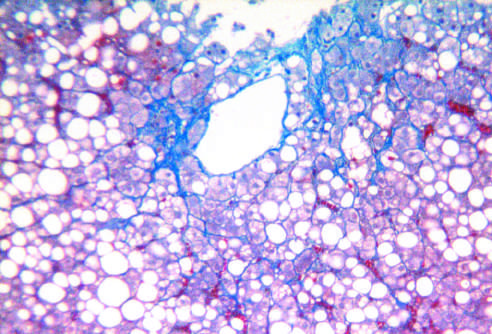what is some fibrosis present in?
Answer the question using a single word or phrase. The characteristic perisinusoidal chicken wire fence pattern 